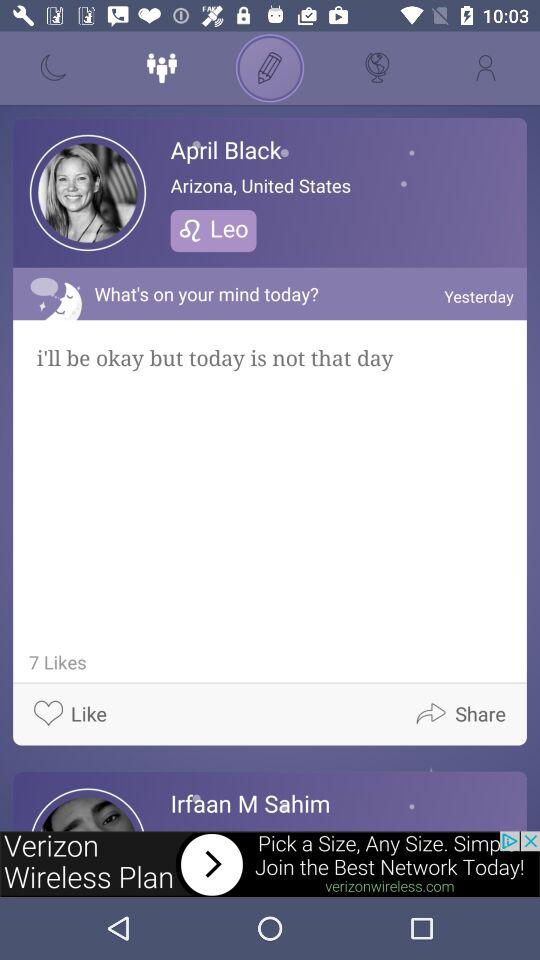What's the Zodiac Sign of April Black? The zodiac sign is Leo. 